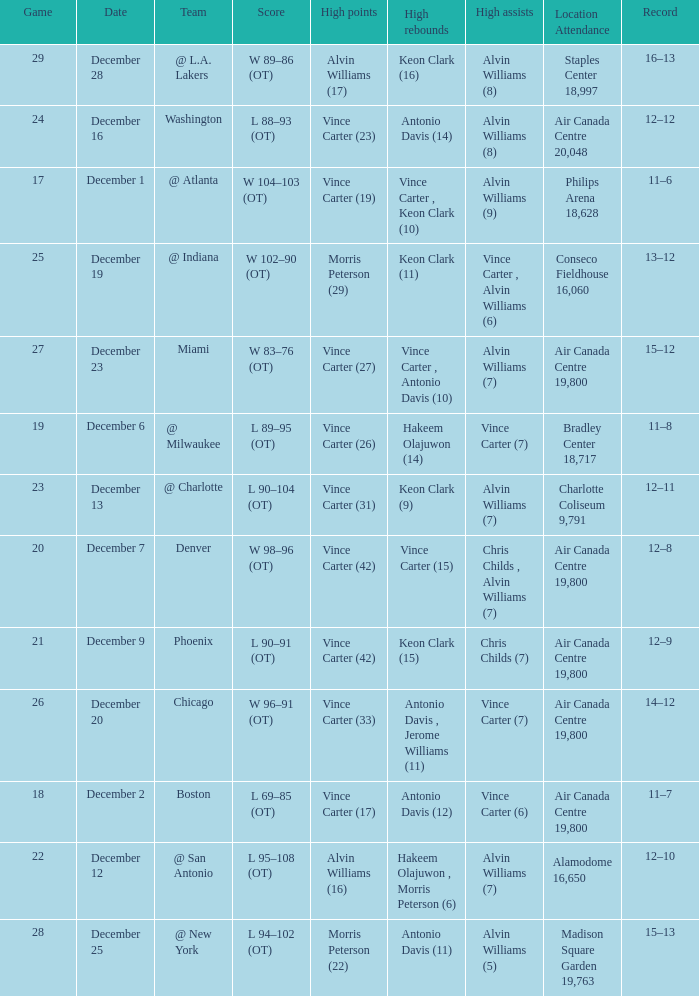What game happened on December 19? 25.0. 